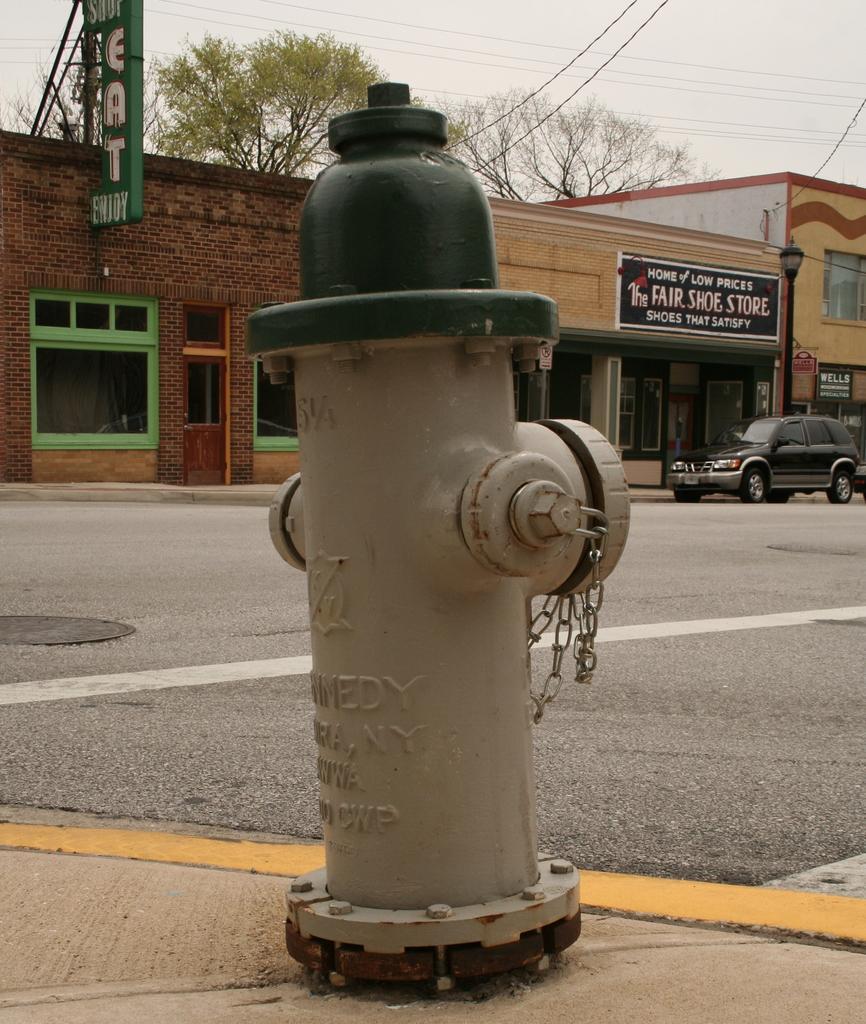Describe this image in one or two sentences. In this image we can see a stand pipe with chain. Also something is written on that. In the back there is a road. Also there is a vehicle. And there is a building with windows and boards. In the background there are trees. Also there is sky. 